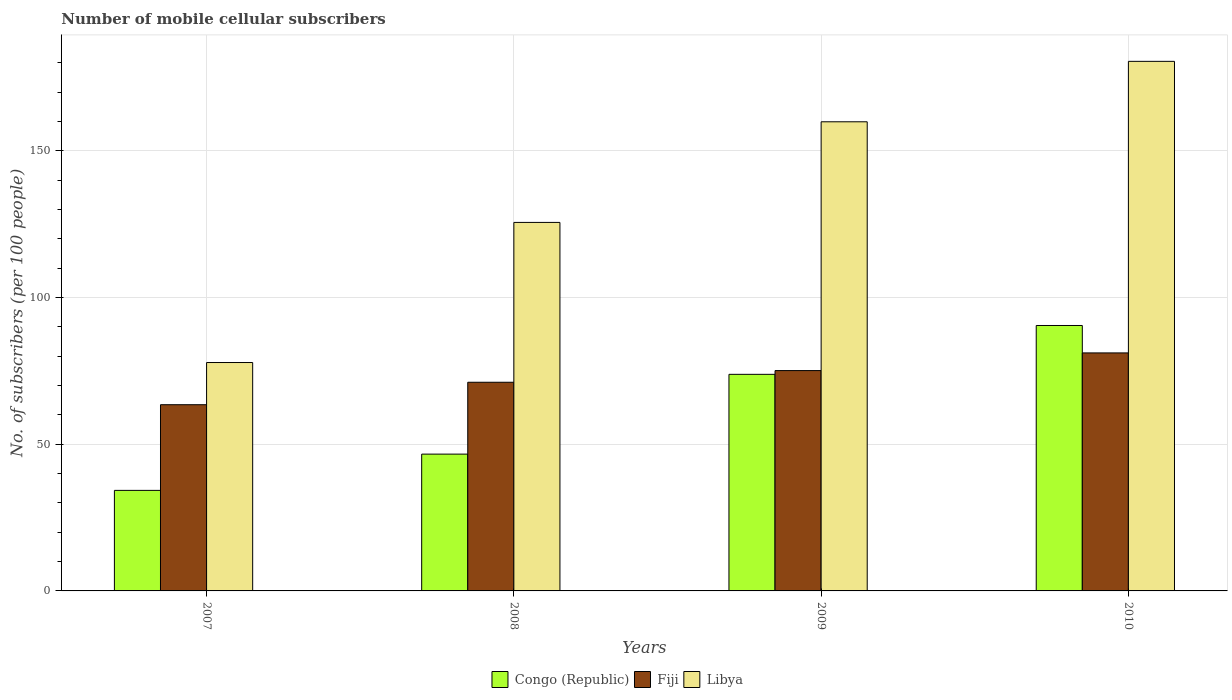How many groups of bars are there?
Your answer should be compact. 4. Are the number of bars per tick equal to the number of legend labels?
Make the answer very short. Yes. Are the number of bars on each tick of the X-axis equal?
Keep it short and to the point. Yes. How many bars are there on the 4th tick from the left?
Offer a terse response. 3. How many bars are there on the 3rd tick from the right?
Your answer should be very brief. 3. In how many cases, is the number of bars for a given year not equal to the number of legend labels?
Provide a succinct answer. 0. What is the number of mobile cellular subscribers in Congo (Republic) in 2010?
Offer a very short reply. 90.44. Across all years, what is the maximum number of mobile cellular subscribers in Fiji?
Offer a very short reply. 81.1. Across all years, what is the minimum number of mobile cellular subscribers in Libya?
Provide a short and direct response. 77.83. In which year was the number of mobile cellular subscribers in Libya maximum?
Offer a very short reply. 2010. In which year was the number of mobile cellular subscribers in Libya minimum?
Provide a short and direct response. 2007. What is the total number of mobile cellular subscribers in Fiji in the graph?
Provide a short and direct response. 290.73. What is the difference between the number of mobile cellular subscribers in Congo (Republic) in 2007 and that in 2008?
Your answer should be compact. -12.36. What is the difference between the number of mobile cellular subscribers in Congo (Republic) in 2008 and the number of mobile cellular subscribers in Libya in 2009?
Your response must be concise. -113.24. What is the average number of mobile cellular subscribers in Fiji per year?
Make the answer very short. 72.68. In the year 2008, what is the difference between the number of mobile cellular subscribers in Fiji and number of mobile cellular subscribers in Congo (Republic)?
Give a very brief answer. 24.49. In how many years, is the number of mobile cellular subscribers in Fiji greater than 120?
Provide a short and direct response. 0. What is the ratio of the number of mobile cellular subscribers in Libya in 2007 to that in 2008?
Offer a terse response. 0.62. Is the difference between the number of mobile cellular subscribers in Fiji in 2007 and 2010 greater than the difference between the number of mobile cellular subscribers in Congo (Republic) in 2007 and 2010?
Offer a very short reply. Yes. What is the difference between the highest and the second highest number of mobile cellular subscribers in Congo (Republic)?
Your response must be concise. 16.65. What is the difference between the highest and the lowest number of mobile cellular subscribers in Libya?
Your response must be concise. 102.62. In how many years, is the number of mobile cellular subscribers in Congo (Republic) greater than the average number of mobile cellular subscribers in Congo (Republic) taken over all years?
Offer a very short reply. 2. Is the sum of the number of mobile cellular subscribers in Congo (Republic) in 2007 and 2009 greater than the maximum number of mobile cellular subscribers in Libya across all years?
Ensure brevity in your answer.  No. What does the 1st bar from the left in 2009 represents?
Offer a terse response. Congo (Republic). What does the 2nd bar from the right in 2010 represents?
Ensure brevity in your answer.  Fiji. How many bars are there?
Provide a succinct answer. 12. Are all the bars in the graph horizontal?
Offer a terse response. No. How many years are there in the graph?
Ensure brevity in your answer.  4. Does the graph contain any zero values?
Keep it short and to the point. No. Does the graph contain grids?
Provide a short and direct response. Yes. What is the title of the graph?
Your response must be concise. Number of mobile cellular subscribers. What is the label or title of the X-axis?
Give a very brief answer. Years. What is the label or title of the Y-axis?
Offer a very short reply. No. of subscribers (per 100 people). What is the No. of subscribers (per 100 people) in Congo (Republic) in 2007?
Make the answer very short. 34.26. What is the No. of subscribers (per 100 people) of Fiji in 2007?
Keep it short and to the point. 63.45. What is the No. of subscribers (per 100 people) in Libya in 2007?
Provide a short and direct response. 77.83. What is the No. of subscribers (per 100 people) in Congo (Republic) in 2008?
Offer a very short reply. 46.61. What is the No. of subscribers (per 100 people) of Fiji in 2008?
Offer a terse response. 71.1. What is the No. of subscribers (per 100 people) of Libya in 2008?
Offer a terse response. 125.56. What is the No. of subscribers (per 100 people) of Congo (Republic) in 2009?
Ensure brevity in your answer.  73.8. What is the No. of subscribers (per 100 people) in Fiji in 2009?
Make the answer very short. 75.08. What is the No. of subscribers (per 100 people) in Libya in 2009?
Ensure brevity in your answer.  159.85. What is the No. of subscribers (per 100 people) in Congo (Republic) in 2010?
Offer a very short reply. 90.44. What is the No. of subscribers (per 100 people) in Fiji in 2010?
Make the answer very short. 81.1. What is the No. of subscribers (per 100 people) of Libya in 2010?
Provide a succinct answer. 180.45. Across all years, what is the maximum No. of subscribers (per 100 people) in Congo (Republic)?
Make the answer very short. 90.44. Across all years, what is the maximum No. of subscribers (per 100 people) of Fiji?
Offer a very short reply. 81.1. Across all years, what is the maximum No. of subscribers (per 100 people) in Libya?
Your answer should be compact. 180.45. Across all years, what is the minimum No. of subscribers (per 100 people) of Congo (Republic)?
Keep it short and to the point. 34.26. Across all years, what is the minimum No. of subscribers (per 100 people) of Fiji?
Give a very brief answer. 63.45. Across all years, what is the minimum No. of subscribers (per 100 people) in Libya?
Your response must be concise. 77.83. What is the total No. of subscribers (per 100 people) in Congo (Republic) in the graph?
Ensure brevity in your answer.  245.11. What is the total No. of subscribers (per 100 people) in Fiji in the graph?
Ensure brevity in your answer.  290.73. What is the total No. of subscribers (per 100 people) of Libya in the graph?
Keep it short and to the point. 543.69. What is the difference between the No. of subscribers (per 100 people) in Congo (Republic) in 2007 and that in 2008?
Your answer should be compact. -12.36. What is the difference between the No. of subscribers (per 100 people) in Fiji in 2007 and that in 2008?
Provide a short and direct response. -7.65. What is the difference between the No. of subscribers (per 100 people) of Libya in 2007 and that in 2008?
Give a very brief answer. -47.74. What is the difference between the No. of subscribers (per 100 people) of Congo (Republic) in 2007 and that in 2009?
Your response must be concise. -39.54. What is the difference between the No. of subscribers (per 100 people) in Fiji in 2007 and that in 2009?
Offer a very short reply. -11.63. What is the difference between the No. of subscribers (per 100 people) of Libya in 2007 and that in 2009?
Your answer should be compact. -82.03. What is the difference between the No. of subscribers (per 100 people) in Congo (Republic) in 2007 and that in 2010?
Provide a succinct answer. -56.19. What is the difference between the No. of subscribers (per 100 people) of Fiji in 2007 and that in 2010?
Offer a terse response. -17.65. What is the difference between the No. of subscribers (per 100 people) in Libya in 2007 and that in 2010?
Provide a succinct answer. -102.62. What is the difference between the No. of subscribers (per 100 people) in Congo (Republic) in 2008 and that in 2009?
Make the answer very short. -27.18. What is the difference between the No. of subscribers (per 100 people) in Fiji in 2008 and that in 2009?
Your answer should be very brief. -3.97. What is the difference between the No. of subscribers (per 100 people) of Libya in 2008 and that in 2009?
Make the answer very short. -34.29. What is the difference between the No. of subscribers (per 100 people) in Congo (Republic) in 2008 and that in 2010?
Your response must be concise. -43.83. What is the difference between the No. of subscribers (per 100 people) in Fiji in 2008 and that in 2010?
Make the answer very short. -10. What is the difference between the No. of subscribers (per 100 people) in Libya in 2008 and that in 2010?
Offer a very short reply. -54.88. What is the difference between the No. of subscribers (per 100 people) of Congo (Republic) in 2009 and that in 2010?
Your answer should be very brief. -16.65. What is the difference between the No. of subscribers (per 100 people) of Fiji in 2009 and that in 2010?
Provide a short and direct response. -6.03. What is the difference between the No. of subscribers (per 100 people) in Libya in 2009 and that in 2010?
Keep it short and to the point. -20.59. What is the difference between the No. of subscribers (per 100 people) of Congo (Republic) in 2007 and the No. of subscribers (per 100 people) of Fiji in 2008?
Your response must be concise. -36.85. What is the difference between the No. of subscribers (per 100 people) of Congo (Republic) in 2007 and the No. of subscribers (per 100 people) of Libya in 2008?
Your response must be concise. -91.31. What is the difference between the No. of subscribers (per 100 people) in Fiji in 2007 and the No. of subscribers (per 100 people) in Libya in 2008?
Make the answer very short. -62.11. What is the difference between the No. of subscribers (per 100 people) in Congo (Republic) in 2007 and the No. of subscribers (per 100 people) in Fiji in 2009?
Keep it short and to the point. -40.82. What is the difference between the No. of subscribers (per 100 people) in Congo (Republic) in 2007 and the No. of subscribers (per 100 people) in Libya in 2009?
Your response must be concise. -125.6. What is the difference between the No. of subscribers (per 100 people) in Fiji in 2007 and the No. of subscribers (per 100 people) in Libya in 2009?
Your answer should be compact. -96.4. What is the difference between the No. of subscribers (per 100 people) of Congo (Republic) in 2007 and the No. of subscribers (per 100 people) of Fiji in 2010?
Make the answer very short. -46.84. What is the difference between the No. of subscribers (per 100 people) in Congo (Republic) in 2007 and the No. of subscribers (per 100 people) in Libya in 2010?
Provide a succinct answer. -146.19. What is the difference between the No. of subscribers (per 100 people) of Fiji in 2007 and the No. of subscribers (per 100 people) of Libya in 2010?
Offer a very short reply. -117. What is the difference between the No. of subscribers (per 100 people) in Congo (Republic) in 2008 and the No. of subscribers (per 100 people) in Fiji in 2009?
Provide a succinct answer. -28.46. What is the difference between the No. of subscribers (per 100 people) of Congo (Republic) in 2008 and the No. of subscribers (per 100 people) of Libya in 2009?
Ensure brevity in your answer.  -113.24. What is the difference between the No. of subscribers (per 100 people) in Fiji in 2008 and the No. of subscribers (per 100 people) in Libya in 2009?
Your answer should be compact. -88.75. What is the difference between the No. of subscribers (per 100 people) in Congo (Republic) in 2008 and the No. of subscribers (per 100 people) in Fiji in 2010?
Ensure brevity in your answer.  -34.49. What is the difference between the No. of subscribers (per 100 people) in Congo (Republic) in 2008 and the No. of subscribers (per 100 people) in Libya in 2010?
Offer a very short reply. -133.83. What is the difference between the No. of subscribers (per 100 people) of Fiji in 2008 and the No. of subscribers (per 100 people) of Libya in 2010?
Offer a terse response. -109.34. What is the difference between the No. of subscribers (per 100 people) in Congo (Republic) in 2009 and the No. of subscribers (per 100 people) in Fiji in 2010?
Provide a succinct answer. -7.3. What is the difference between the No. of subscribers (per 100 people) in Congo (Republic) in 2009 and the No. of subscribers (per 100 people) in Libya in 2010?
Your response must be concise. -106.65. What is the difference between the No. of subscribers (per 100 people) of Fiji in 2009 and the No. of subscribers (per 100 people) of Libya in 2010?
Keep it short and to the point. -105.37. What is the average No. of subscribers (per 100 people) in Congo (Republic) per year?
Your response must be concise. 61.28. What is the average No. of subscribers (per 100 people) in Fiji per year?
Provide a short and direct response. 72.68. What is the average No. of subscribers (per 100 people) of Libya per year?
Offer a very short reply. 135.92. In the year 2007, what is the difference between the No. of subscribers (per 100 people) of Congo (Republic) and No. of subscribers (per 100 people) of Fiji?
Offer a terse response. -29.19. In the year 2007, what is the difference between the No. of subscribers (per 100 people) of Congo (Republic) and No. of subscribers (per 100 people) of Libya?
Provide a short and direct response. -43.57. In the year 2007, what is the difference between the No. of subscribers (per 100 people) of Fiji and No. of subscribers (per 100 people) of Libya?
Offer a terse response. -14.38. In the year 2008, what is the difference between the No. of subscribers (per 100 people) in Congo (Republic) and No. of subscribers (per 100 people) in Fiji?
Give a very brief answer. -24.49. In the year 2008, what is the difference between the No. of subscribers (per 100 people) in Congo (Republic) and No. of subscribers (per 100 people) in Libya?
Your answer should be very brief. -78.95. In the year 2008, what is the difference between the No. of subscribers (per 100 people) in Fiji and No. of subscribers (per 100 people) in Libya?
Make the answer very short. -54.46. In the year 2009, what is the difference between the No. of subscribers (per 100 people) of Congo (Republic) and No. of subscribers (per 100 people) of Fiji?
Your answer should be very brief. -1.28. In the year 2009, what is the difference between the No. of subscribers (per 100 people) in Congo (Republic) and No. of subscribers (per 100 people) in Libya?
Ensure brevity in your answer.  -86.05. In the year 2009, what is the difference between the No. of subscribers (per 100 people) of Fiji and No. of subscribers (per 100 people) of Libya?
Ensure brevity in your answer.  -84.78. In the year 2010, what is the difference between the No. of subscribers (per 100 people) of Congo (Republic) and No. of subscribers (per 100 people) of Fiji?
Your response must be concise. 9.34. In the year 2010, what is the difference between the No. of subscribers (per 100 people) in Congo (Republic) and No. of subscribers (per 100 people) in Libya?
Your response must be concise. -90. In the year 2010, what is the difference between the No. of subscribers (per 100 people) of Fiji and No. of subscribers (per 100 people) of Libya?
Offer a very short reply. -99.34. What is the ratio of the No. of subscribers (per 100 people) of Congo (Republic) in 2007 to that in 2008?
Your response must be concise. 0.73. What is the ratio of the No. of subscribers (per 100 people) of Fiji in 2007 to that in 2008?
Ensure brevity in your answer.  0.89. What is the ratio of the No. of subscribers (per 100 people) of Libya in 2007 to that in 2008?
Keep it short and to the point. 0.62. What is the ratio of the No. of subscribers (per 100 people) of Congo (Republic) in 2007 to that in 2009?
Your response must be concise. 0.46. What is the ratio of the No. of subscribers (per 100 people) in Fiji in 2007 to that in 2009?
Make the answer very short. 0.85. What is the ratio of the No. of subscribers (per 100 people) in Libya in 2007 to that in 2009?
Keep it short and to the point. 0.49. What is the ratio of the No. of subscribers (per 100 people) of Congo (Republic) in 2007 to that in 2010?
Provide a short and direct response. 0.38. What is the ratio of the No. of subscribers (per 100 people) of Fiji in 2007 to that in 2010?
Ensure brevity in your answer.  0.78. What is the ratio of the No. of subscribers (per 100 people) in Libya in 2007 to that in 2010?
Offer a terse response. 0.43. What is the ratio of the No. of subscribers (per 100 people) in Congo (Republic) in 2008 to that in 2009?
Your answer should be very brief. 0.63. What is the ratio of the No. of subscribers (per 100 people) in Fiji in 2008 to that in 2009?
Make the answer very short. 0.95. What is the ratio of the No. of subscribers (per 100 people) in Libya in 2008 to that in 2009?
Keep it short and to the point. 0.79. What is the ratio of the No. of subscribers (per 100 people) of Congo (Republic) in 2008 to that in 2010?
Make the answer very short. 0.52. What is the ratio of the No. of subscribers (per 100 people) in Fiji in 2008 to that in 2010?
Keep it short and to the point. 0.88. What is the ratio of the No. of subscribers (per 100 people) in Libya in 2008 to that in 2010?
Your answer should be compact. 0.7. What is the ratio of the No. of subscribers (per 100 people) of Congo (Republic) in 2009 to that in 2010?
Ensure brevity in your answer.  0.82. What is the ratio of the No. of subscribers (per 100 people) of Fiji in 2009 to that in 2010?
Offer a very short reply. 0.93. What is the ratio of the No. of subscribers (per 100 people) of Libya in 2009 to that in 2010?
Give a very brief answer. 0.89. What is the difference between the highest and the second highest No. of subscribers (per 100 people) in Congo (Republic)?
Your response must be concise. 16.65. What is the difference between the highest and the second highest No. of subscribers (per 100 people) of Fiji?
Give a very brief answer. 6.03. What is the difference between the highest and the second highest No. of subscribers (per 100 people) of Libya?
Your response must be concise. 20.59. What is the difference between the highest and the lowest No. of subscribers (per 100 people) of Congo (Republic)?
Provide a short and direct response. 56.19. What is the difference between the highest and the lowest No. of subscribers (per 100 people) of Fiji?
Keep it short and to the point. 17.65. What is the difference between the highest and the lowest No. of subscribers (per 100 people) in Libya?
Your answer should be compact. 102.62. 